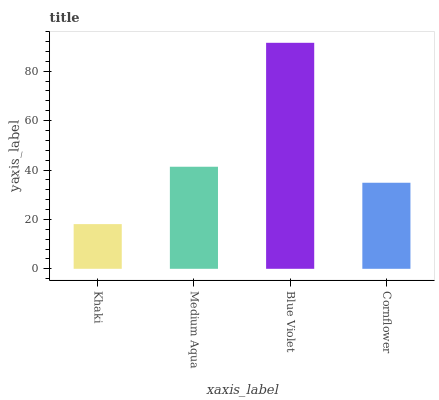Is Medium Aqua the minimum?
Answer yes or no. No. Is Medium Aqua the maximum?
Answer yes or no. No. Is Medium Aqua greater than Khaki?
Answer yes or no. Yes. Is Khaki less than Medium Aqua?
Answer yes or no. Yes. Is Khaki greater than Medium Aqua?
Answer yes or no. No. Is Medium Aqua less than Khaki?
Answer yes or no. No. Is Medium Aqua the high median?
Answer yes or no. Yes. Is Cornflower the low median?
Answer yes or no. Yes. Is Khaki the high median?
Answer yes or no. No. Is Khaki the low median?
Answer yes or no. No. 